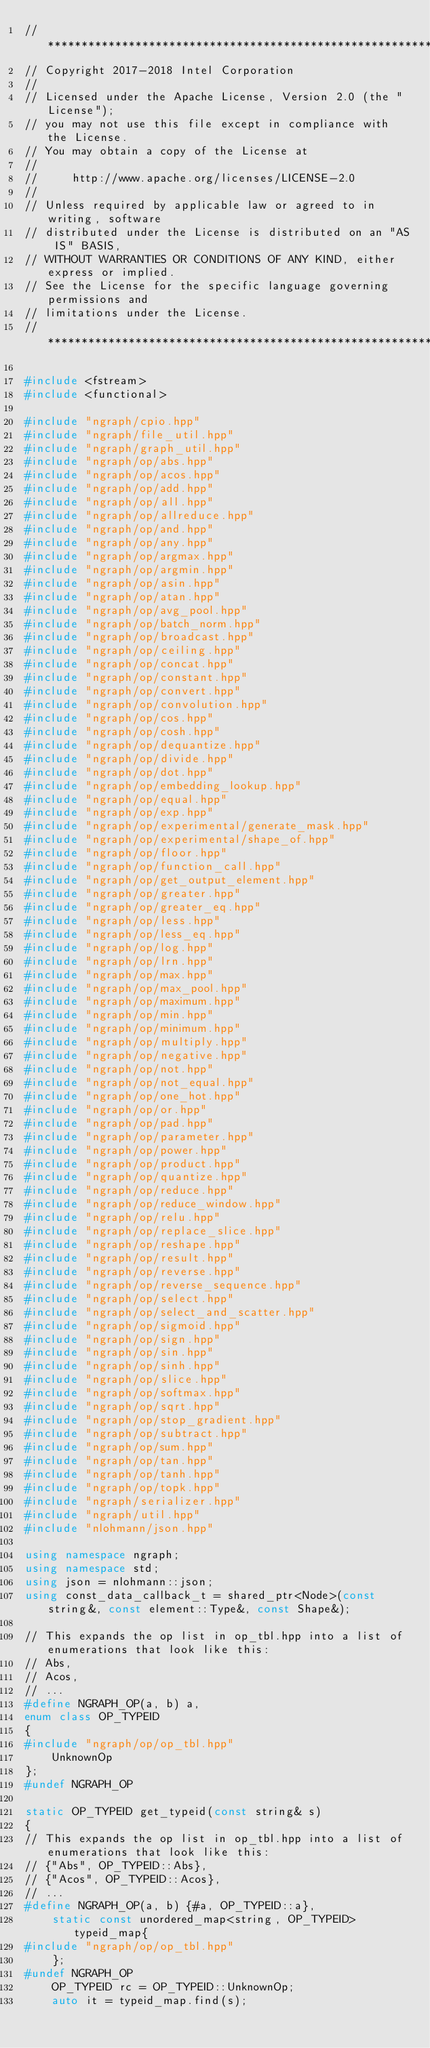<code> <loc_0><loc_0><loc_500><loc_500><_C++_>//*****************************************************************************
// Copyright 2017-2018 Intel Corporation
//
// Licensed under the Apache License, Version 2.0 (the "License");
// you may not use this file except in compliance with the License.
// You may obtain a copy of the License at
//
//     http://www.apache.org/licenses/LICENSE-2.0
//
// Unless required by applicable law or agreed to in writing, software
// distributed under the License is distributed on an "AS IS" BASIS,
// WITHOUT WARRANTIES OR CONDITIONS OF ANY KIND, either express or implied.
// See the License for the specific language governing permissions and
// limitations under the License.
//*****************************************************************************

#include <fstream>
#include <functional>

#include "ngraph/cpio.hpp"
#include "ngraph/file_util.hpp"
#include "ngraph/graph_util.hpp"
#include "ngraph/op/abs.hpp"
#include "ngraph/op/acos.hpp"
#include "ngraph/op/add.hpp"
#include "ngraph/op/all.hpp"
#include "ngraph/op/allreduce.hpp"
#include "ngraph/op/and.hpp"
#include "ngraph/op/any.hpp"
#include "ngraph/op/argmax.hpp"
#include "ngraph/op/argmin.hpp"
#include "ngraph/op/asin.hpp"
#include "ngraph/op/atan.hpp"
#include "ngraph/op/avg_pool.hpp"
#include "ngraph/op/batch_norm.hpp"
#include "ngraph/op/broadcast.hpp"
#include "ngraph/op/ceiling.hpp"
#include "ngraph/op/concat.hpp"
#include "ngraph/op/constant.hpp"
#include "ngraph/op/convert.hpp"
#include "ngraph/op/convolution.hpp"
#include "ngraph/op/cos.hpp"
#include "ngraph/op/cosh.hpp"
#include "ngraph/op/dequantize.hpp"
#include "ngraph/op/divide.hpp"
#include "ngraph/op/dot.hpp"
#include "ngraph/op/embedding_lookup.hpp"
#include "ngraph/op/equal.hpp"
#include "ngraph/op/exp.hpp"
#include "ngraph/op/experimental/generate_mask.hpp"
#include "ngraph/op/experimental/shape_of.hpp"
#include "ngraph/op/floor.hpp"
#include "ngraph/op/function_call.hpp"
#include "ngraph/op/get_output_element.hpp"
#include "ngraph/op/greater.hpp"
#include "ngraph/op/greater_eq.hpp"
#include "ngraph/op/less.hpp"
#include "ngraph/op/less_eq.hpp"
#include "ngraph/op/log.hpp"
#include "ngraph/op/lrn.hpp"
#include "ngraph/op/max.hpp"
#include "ngraph/op/max_pool.hpp"
#include "ngraph/op/maximum.hpp"
#include "ngraph/op/min.hpp"
#include "ngraph/op/minimum.hpp"
#include "ngraph/op/multiply.hpp"
#include "ngraph/op/negative.hpp"
#include "ngraph/op/not.hpp"
#include "ngraph/op/not_equal.hpp"
#include "ngraph/op/one_hot.hpp"
#include "ngraph/op/or.hpp"
#include "ngraph/op/pad.hpp"
#include "ngraph/op/parameter.hpp"
#include "ngraph/op/power.hpp"
#include "ngraph/op/product.hpp"
#include "ngraph/op/quantize.hpp"
#include "ngraph/op/reduce.hpp"
#include "ngraph/op/reduce_window.hpp"
#include "ngraph/op/relu.hpp"
#include "ngraph/op/replace_slice.hpp"
#include "ngraph/op/reshape.hpp"
#include "ngraph/op/result.hpp"
#include "ngraph/op/reverse.hpp"
#include "ngraph/op/reverse_sequence.hpp"
#include "ngraph/op/select.hpp"
#include "ngraph/op/select_and_scatter.hpp"
#include "ngraph/op/sigmoid.hpp"
#include "ngraph/op/sign.hpp"
#include "ngraph/op/sin.hpp"
#include "ngraph/op/sinh.hpp"
#include "ngraph/op/slice.hpp"
#include "ngraph/op/softmax.hpp"
#include "ngraph/op/sqrt.hpp"
#include "ngraph/op/stop_gradient.hpp"
#include "ngraph/op/subtract.hpp"
#include "ngraph/op/sum.hpp"
#include "ngraph/op/tan.hpp"
#include "ngraph/op/tanh.hpp"
#include "ngraph/op/topk.hpp"
#include "ngraph/serializer.hpp"
#include "ngraph/util.hpp"
#include "nlohmann/json.hpp"

using namespace ngraph;
using namespace std;
using json = nlohmann::json;
using const_data_callback_t = shared_ptr<Node>(const string&, const element::Type&, const Shape&);

// This expands the op list in op_tbl.hpp into a list of enumerations that look like this:
// Abs,
// Acos,
// ...
#define NGRAPH_OP(a, b) a,
enum class OP_TYPEID
{
#include "ngraph/op/op_tbl.hpp"
    UnknownOp
};
#undef NGRAPH_OP

static OP_TYPEID get_typeid(const string& s)
{
// This expands the op list in op_tbl.hpp into a list of enumerations that look like this:
// {"Abs", OP_TYPEID::Abs},
// {"Acos", OP_TYPEID::Acos},
// ...
#define NGRAPH_OP(a, b) {#a, OP_TYPEID::a},
    static const unordered_map<string, OP_TYPEID> typeid_map{
#include "ngraph/op/op_tbl.hpp"
    };
#undef NGRAPH_OP
    OP_TYPEID rc = OP_TYPEID::UnknownOp;
    auto it = typeid_map.find(s);</code> 